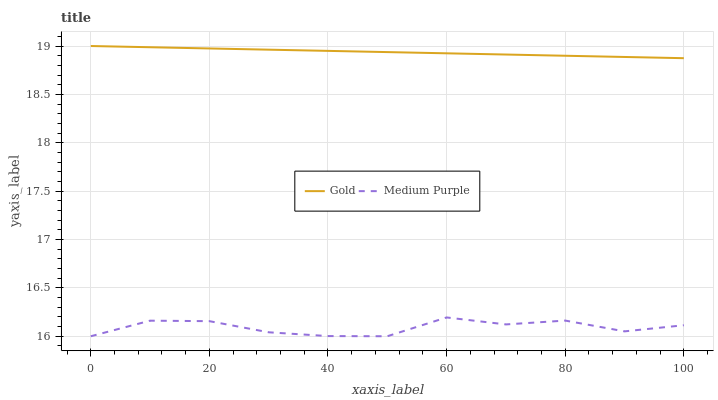Does Medium Purple have the minimum area under the curve?
Answer yes or no. Yes. Does Gold have the maximum area under the curve?
Answer yes or no. Yes. Does Gold have the minimum area under the curve?
Answer yes or no. No. Is Gold the smoothest?
Answer yes or no. Yes. Is Medium Purple the roughest?
Answer yes or no. Yes. Is Gold the roughest?
Answer yes or no. No. Does Medium Purple have the lowest value?
Answer yes or no. Yes. Does Gold have the lowest value?
Answer yes or no. No. Does Gold have the highest value?
Answer yes or no. Yes. Is Medium Purple less than Gold?
Answer yes or no. Yes. Is Gold greater than Medium Purple?
Answer yes or no. Yes. Does Medium Purple intersect Gold?
Answer yes or no. No. 